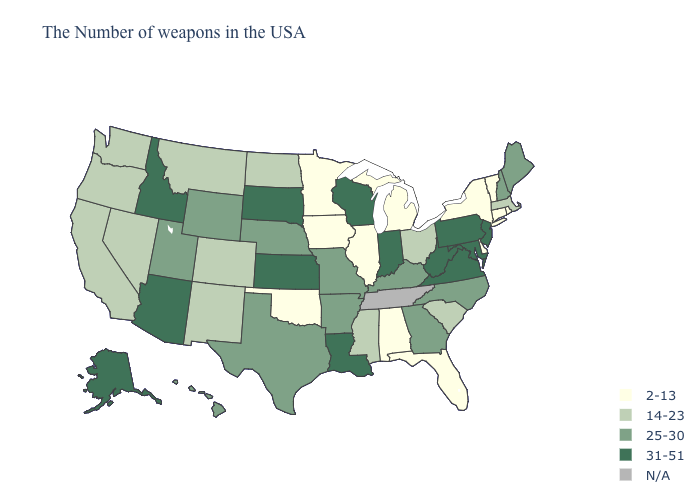What is the lowest value in the USA?
Keep it brief. 2-13. Name the states that have a value in the range 2-13?
Concise answer only. Rhode Island, Vermont, Connecticut, New York, Delaware, Florida, Michigan, Alabama, Illinois, Minnesota, Iowa, Oklahoma. Name the states that have a value in the range 31-51?
Short answer required. New Jersey, Maryland, Pennsylvania, Virginia, West Virginia, Indiana, Wisconsin, Louisiana, Kansas, South Dakota, Arizona, Idaho, Alaska. Does North Dakota have the highest value in the USA?
Be succinct. No. What is the value of West Virginia?
Keep it brief. 31-51. What is the lowest value in states that border Delaware?
Quick response, please. 31-51. Name the states that have a value in the range 14-23?
Concise answer only. Massachusetts, South Carolina, Ohio, Mississippi, North Dakota, Colorado, New Mexico, Montana, Nevada, California, Washington, Oregon. What is the value of Utah?
Quick response, please. 25-30. Does the first symbol in the legend represent the smallest category?
Short answer required. Yes. What is the value of New Hampshire?
Quick response, please. 25-30. Among the states that border Massachusetts , which have the highest value?
Concise answer only. New Hampshire. What is the lowest value in the West?
Short answer required. 14-23. Is the legend a continuous bar?
Short answer required. No. What is the value of Indiana?
Be succinct. 31-51. 